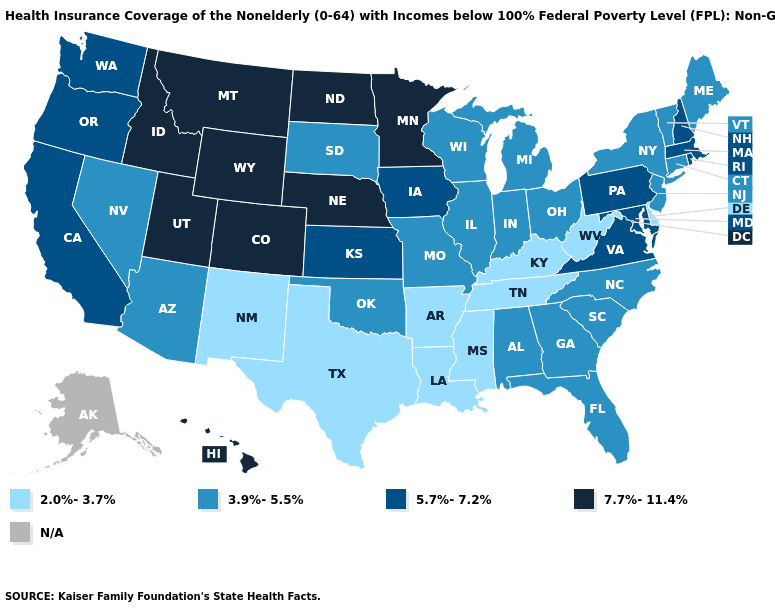What is the highest value in states that border Kansas?
Be succinct. 7.7%-11.4%. Which states have the highest value in the USA?
Short answer required. Colorado, Hawaii, Idaho, Minnesota, Montana, Nebraska, North Dakota, Utah, Wyoming. What is the value of New York?
Write a very short answer. 3.9%-5.5%. Which states have the lowest value in the West?
Give a very brief answer. New Mexico. Name the states that have a value in the range N/A?
Answer briefly. Alaska. What is the value of Idaho?
Concise answer only. 7.7%-11.4%. Does Colorado have the highest value in the USA?
Concise answer only. Yes. Which states have the highest value in the USA?
Quick response, please. Colorado, Hawaii, Idaho, Minnesota, Montana, Nebraska, North Dakota, Utah, Wyoming. Which states have the lowest value in the USA?
Concise answer only. Arkansas, Delaware, Kentucky, Louisiana, Mississippi, New Mexico, Tennessee, Texas, West Virginia. Name the states that have a value in the range 7.7%-11.4%?
Concise answer only. Colorado, Hawaii, Idaho, Minnesota, Montana, Nebraska, North Dakota, Utah, Wyoming. What is the value of Idaho?
Quick response, please. 7.7%-11.4%. Name the states that have a value in the range 7.7%-11.4%?
Give a very brief answer. Colorado, Hawaii, Idaho, Minnesota, Montana, Nebraska, North Dakota, Utah, Wyoming. Name the states that have a value in the range 5.7%-7.2%?
Short answer required. California, Iowa, Kansas, Maryland, Massachusetts, New Hampshire, Oregon, Pennsylvania, Rhode Island, Virginia, Washington. Which states have the highest value in the USA?
Short answer required. Colorado, Hawaii, Idaho, Minnesota, Montana, Nebraska, North Dakota, Utah, Wyoming. 